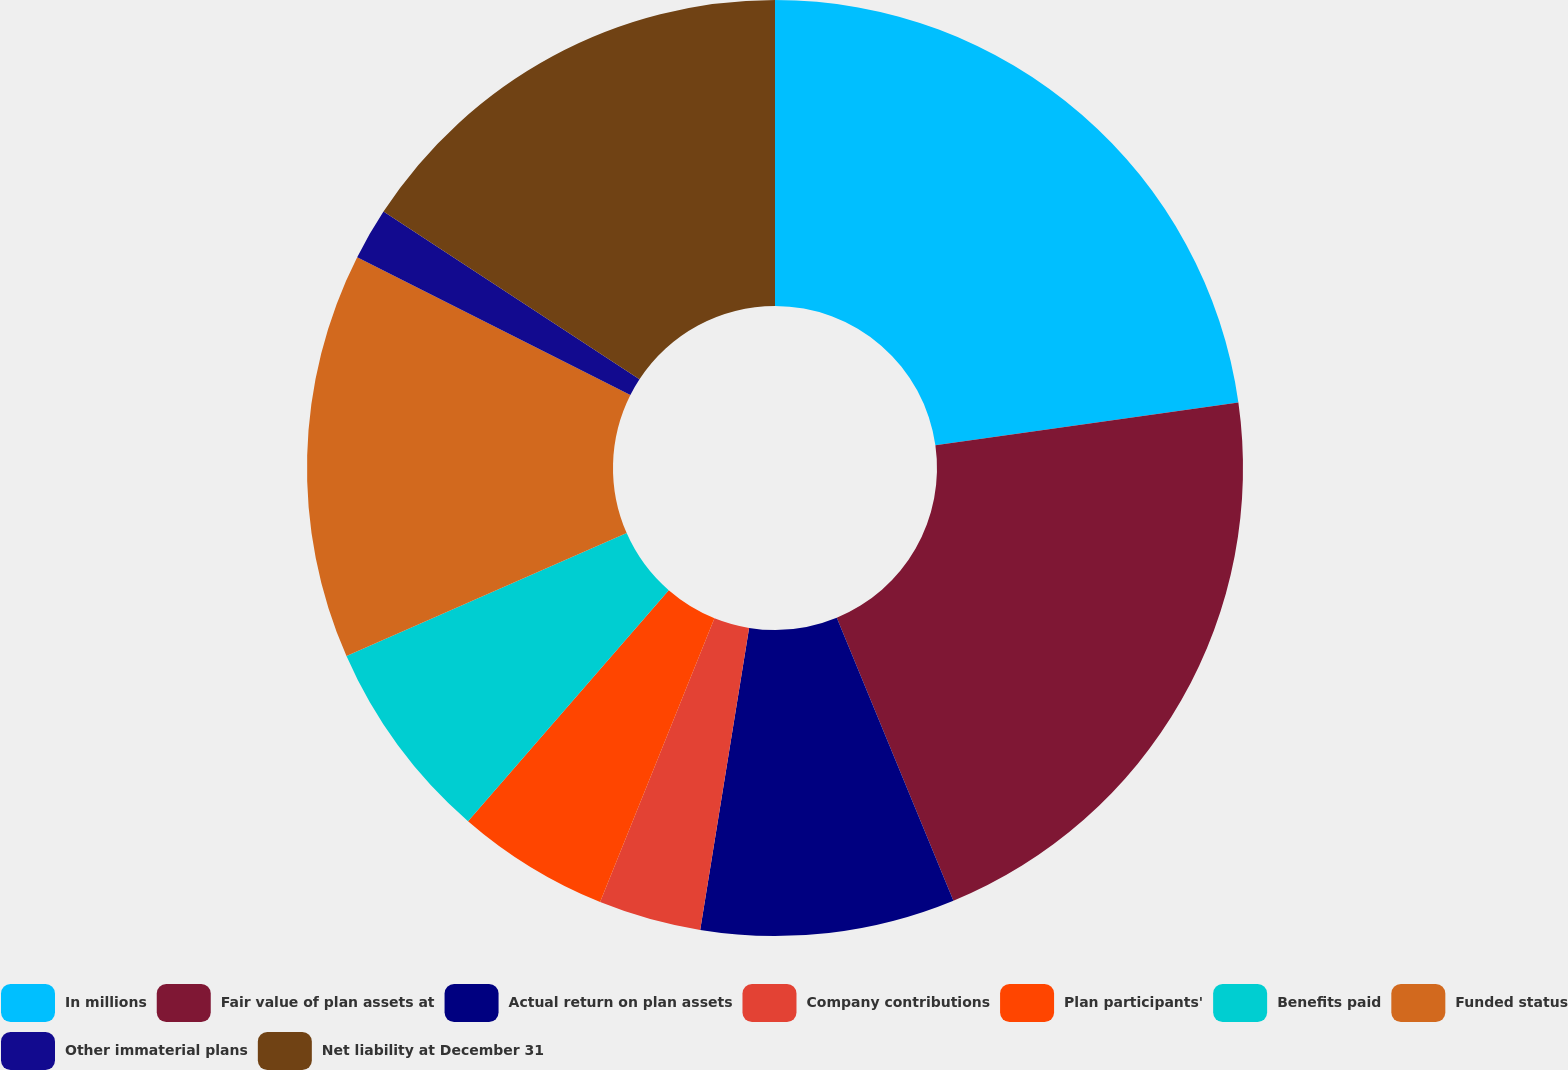<chart> <loc_0><loc_0><loc_500><loc_500><pie_chart><fcel>In millions<fcel>Fair value of plan assets at<fcel>Actual return on plan assets<fcel>Company contributions<fcel>Plan participants'<fcel>Benefits paid<fcel>Funded status<fcel>Other immaterial plans<fcel>Net liability at December 31<nl><fcel>22.76%<fcel>21.01%<fcel>8.78%<fcel>3.54%<fcel>5.29%<fcel>7.03%<fcel>14.02%<fcel>1.79%<fcel>15.77%<nl></chart> 